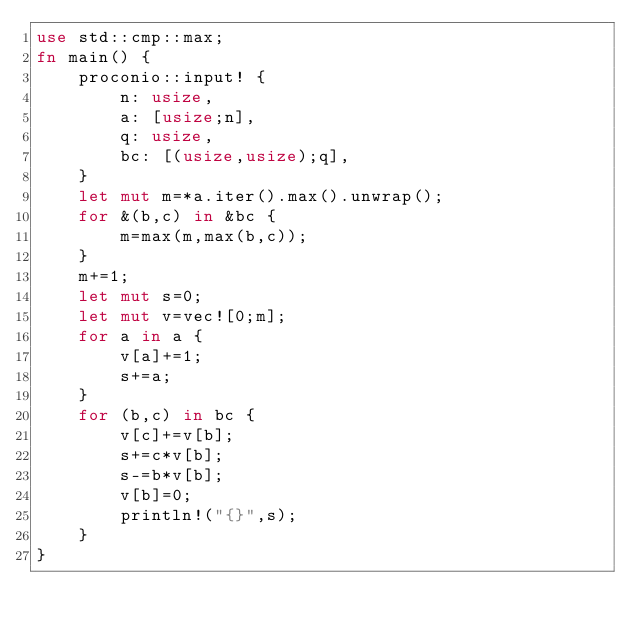<code> <loc_0><loc_0><loc_500><loc_500><_Rust_>use std::cmp::max;
fn main() {
    proconio::input! {
        n: usize,
        a: [usize;n],
        q: usize,
        bc: [(usize,usize);q],
    }
    let mut m=*a.iter().max().unwrap();
    for &(b,c) in &bc {
        m=max(m,max(b,c));
    }
    m+=1;
    let mut s=0;
    let mut v=vec![0;m];
    for a in a {
        v[a]+=1;
        s+=a;
    }
    for (b,c) in bc {
        v[c]+=v[b];
        s+=c*v[b];
        s-=b*v[b];
        v[b]=0;
        println!("{}",s);
    }
}</code> 